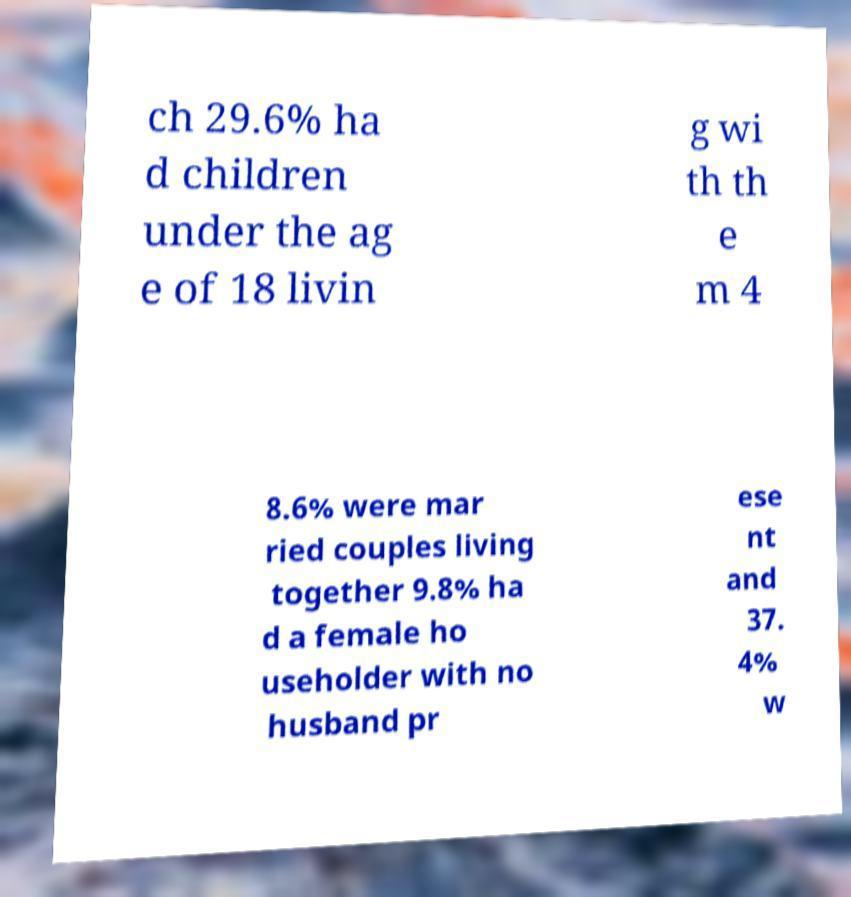Please identify and transcribe the text found in this image. ch 29.6% ha d children under the ag e of 18 livin g wi th th e m 4 8.6% were mar ried couples living together 9.8% ha d a female ho useholder with no husband pr ese nt and 37. 4% w 